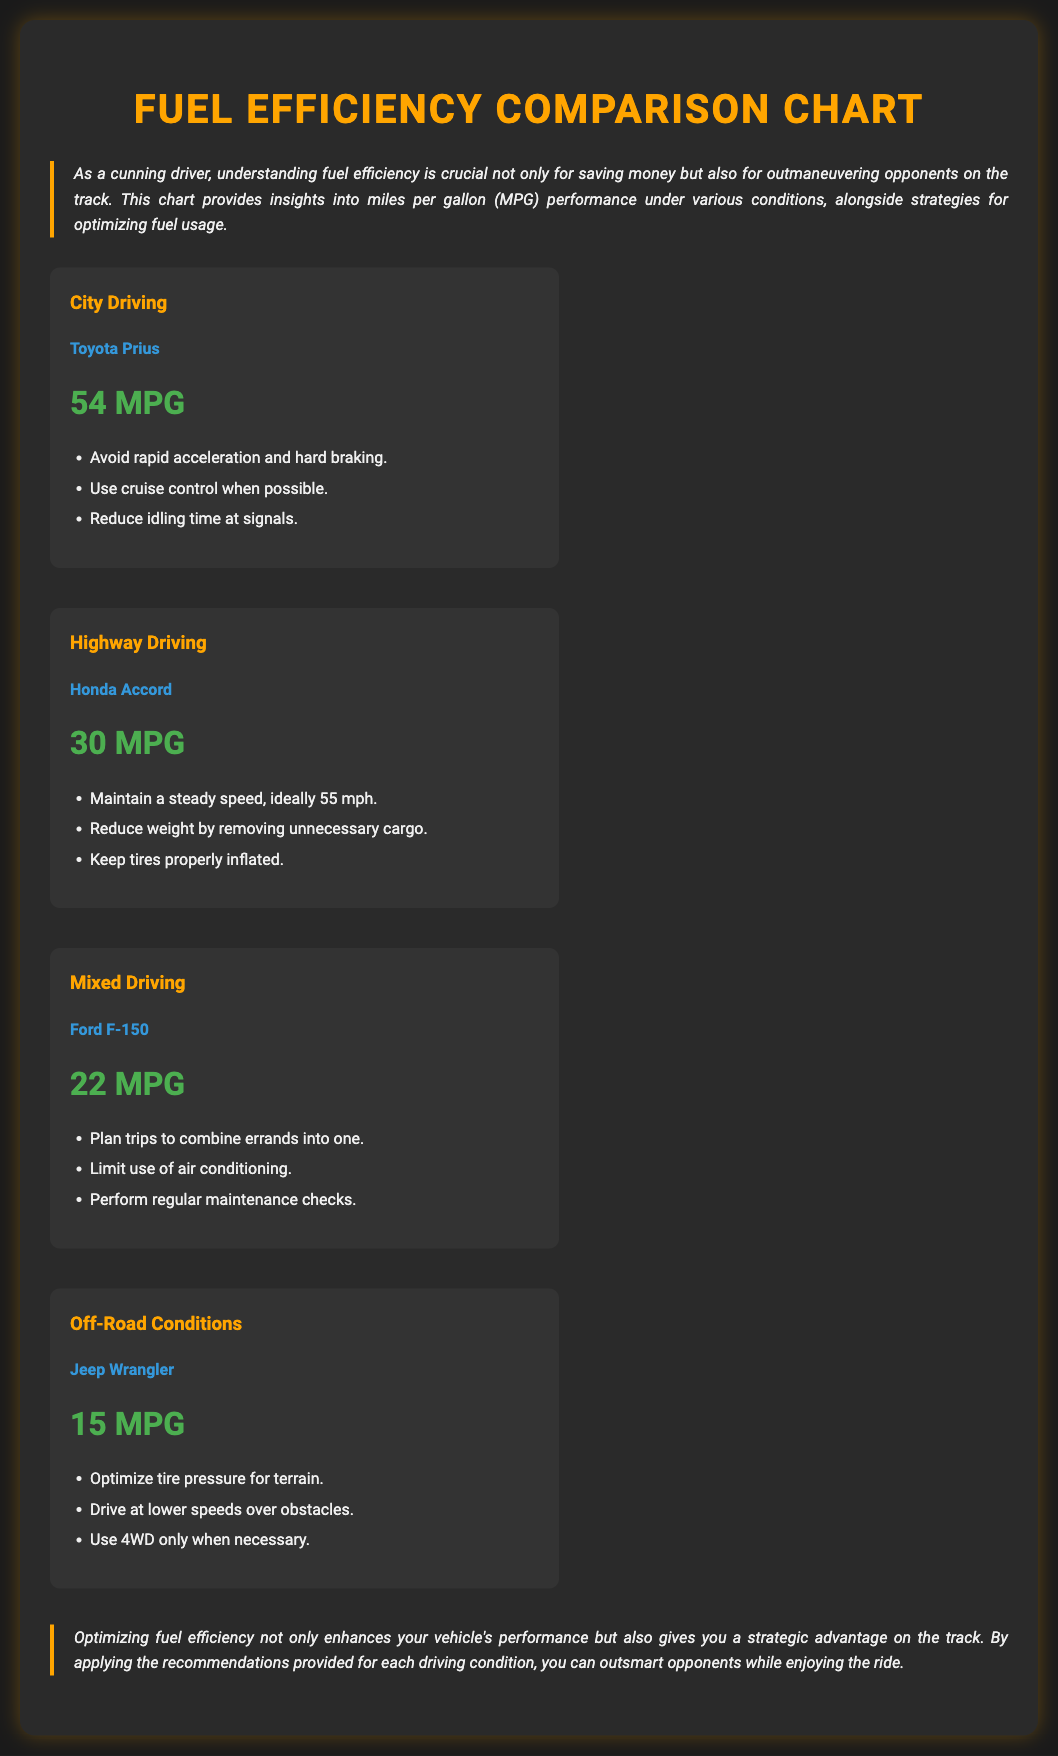What is the MPG for City Driving? The MPG for City Driving is listed under the Toyota Prius section of the document, which is 54 MPG.
Answer: 54 MPG What vehicle is associated with Highway Driving? The document mentions Honda Accord as the vehicle for the Highway Driving condition.
Answer: Honda Accord What is one recommendation for optimizing fuel usage in Off-Road Conditions? The document provides optimization strategies; one of them is to "Optimize tire pressure for terrain."
Answer: Optimize tire pressure for terrain Which driving condition has the lowest fuel efficiency? The MPG values for different conditions are compared, and Off-Road Conditions with a Jeep Wrangler has the lowest at 15 MPG.
Answer: Off-Road Conditions How many MPG does the Ford F-150 achieve in Mixed Driving? The MPG for the Ford F-150 under Mixed Driving is explicitly stated in the document as 22 MPG.
Answer: 22 MPG What is the suggested speed to maintain for optimal Highway Driving MPG? The document recommends maintaining a steady speed of 55 mph for optimal fuel efficiency while driving on the highway.
Answer: 55 mph List one way to improve fuel efficiency in City Driving. One way mentioned in the document is to "Reduce idling time at signals."
Answer: Reduce idling time at signals What is the main purpose of the Fuel Efficiency Comparison Chart? The introduction of the document clarifies that the purpose is to provide insights into MPG performance and strategies for optimizing fuel usage.
Answer: Provide insights into MPG performance and strategies for optimizing fuel usage 